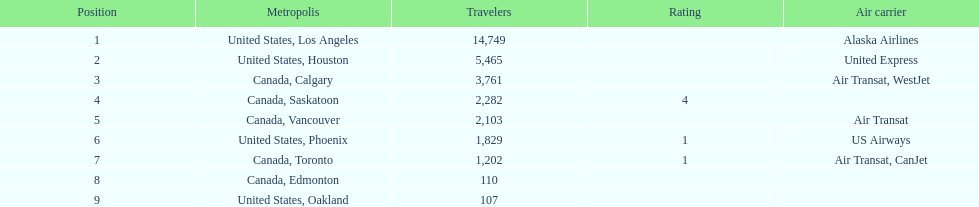How many airlines have a steady ranking? 4. Give me the full table as a dictionary. {'header': ['Position', 'Metropolis', 'Travelers', 'Rating', 'Air carrier'], 'rows': [['1', 'United States, Los Angeles', '14,749', '', 'Alaska Airlines'], ['2', 'United States, Houston', '5,465', '', 'United Express'], ['3', 'Canada, Calgary', '3,761', '', 'Air Transat, WestJet'], ['4', 'Canada, Saskatoon', '2,282', '4', ''], ['5', 'Canada, Vancouver', '2,103', '', 'Air Transat'], ['6', 'United States, Phoenix', '1,829', '1', 'US Airways'], ['7', 'Canada, Toronto', '1,202', '1', 'Air Transat, CanJet'], ['8', 'Canada, Edmonton', '110', '', ''], ['9', 'United States, Oakland', '107', '', '']]} 